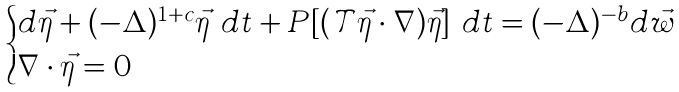<formula> <loc_0><loc_0><loc_500><loc_500>\begin{cases} d \vec { \eta } + ( - \Delta ) ^ { 1 + c } \vec { \eta } \ d t + P [ ( \mathcal { T } \vec { \eta } \cdot \nabla ) \vec { \eta } ] \ d t = ( - \Delta ) ^ { - b } d \vec { w } \\ \nabla \cdot \vec { \eta } = 0 \end{cases}</formula> 